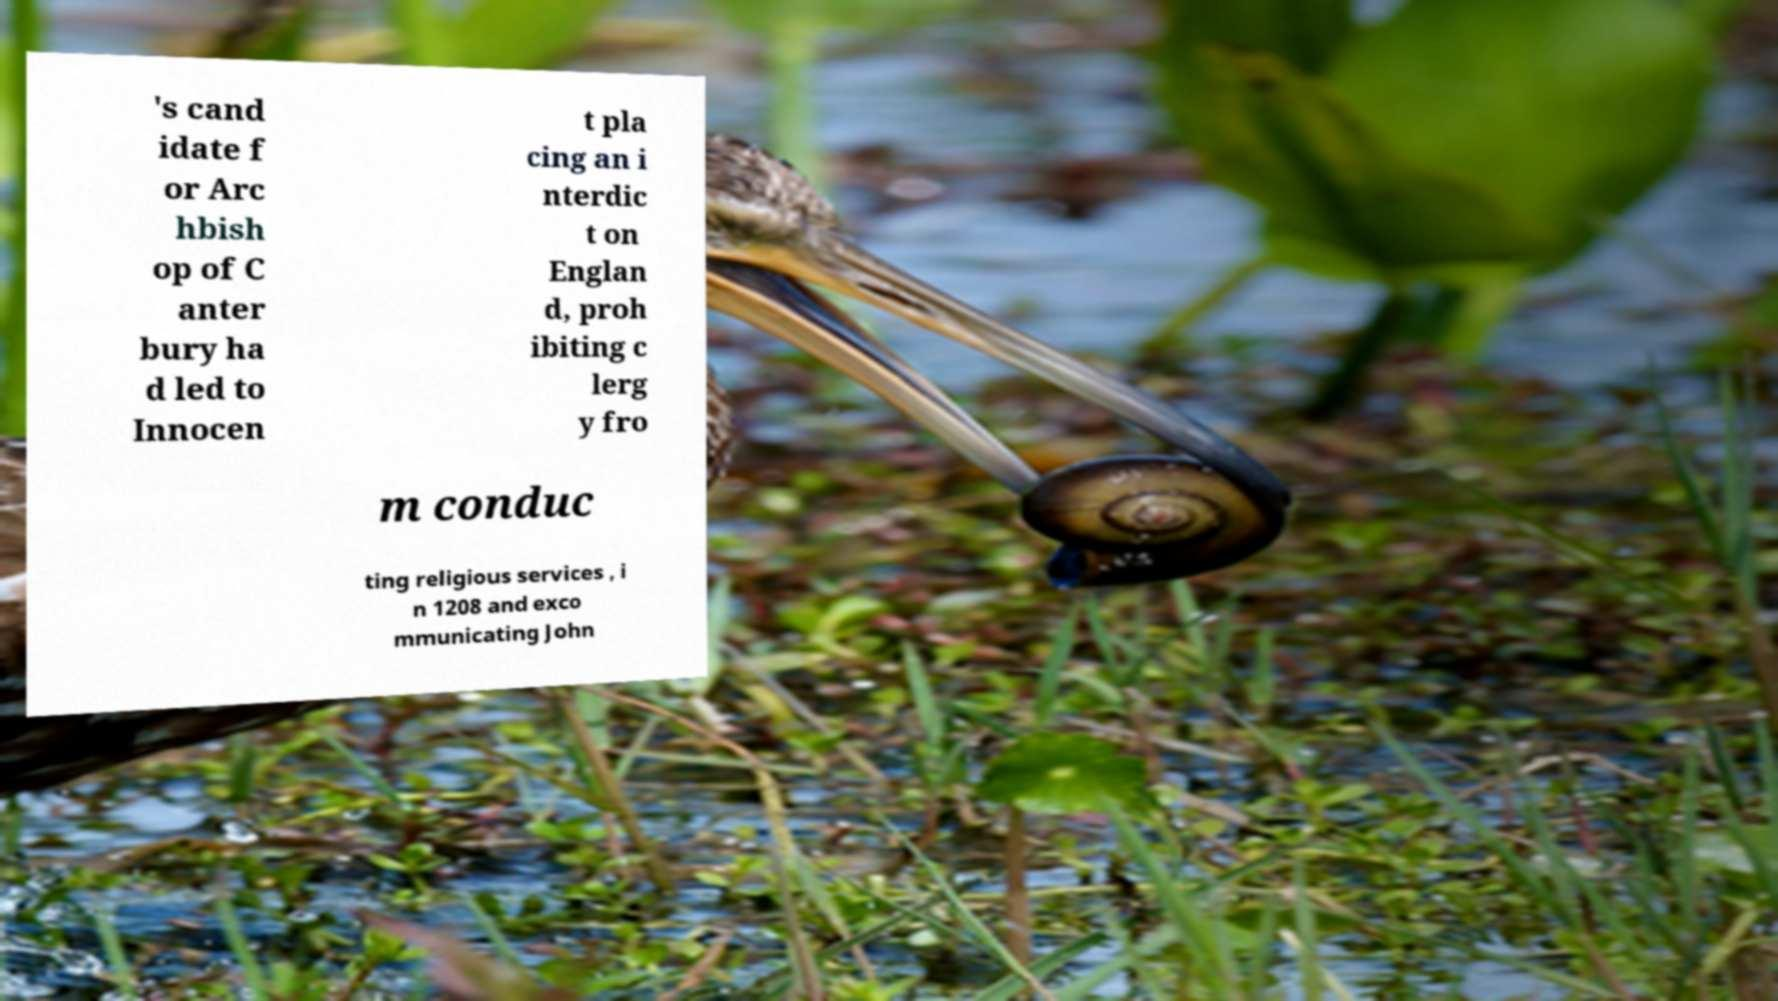I need the written content from this picture converted into text. Can you do that? 's cand idate f or Arc hbish op of C anter bury ha d led to Innocen t pla cing an i nterdic t on Englan d, proh ibiting c lerg y fro m conduc ting religious services , i n 1208 and exco mmunicating John 